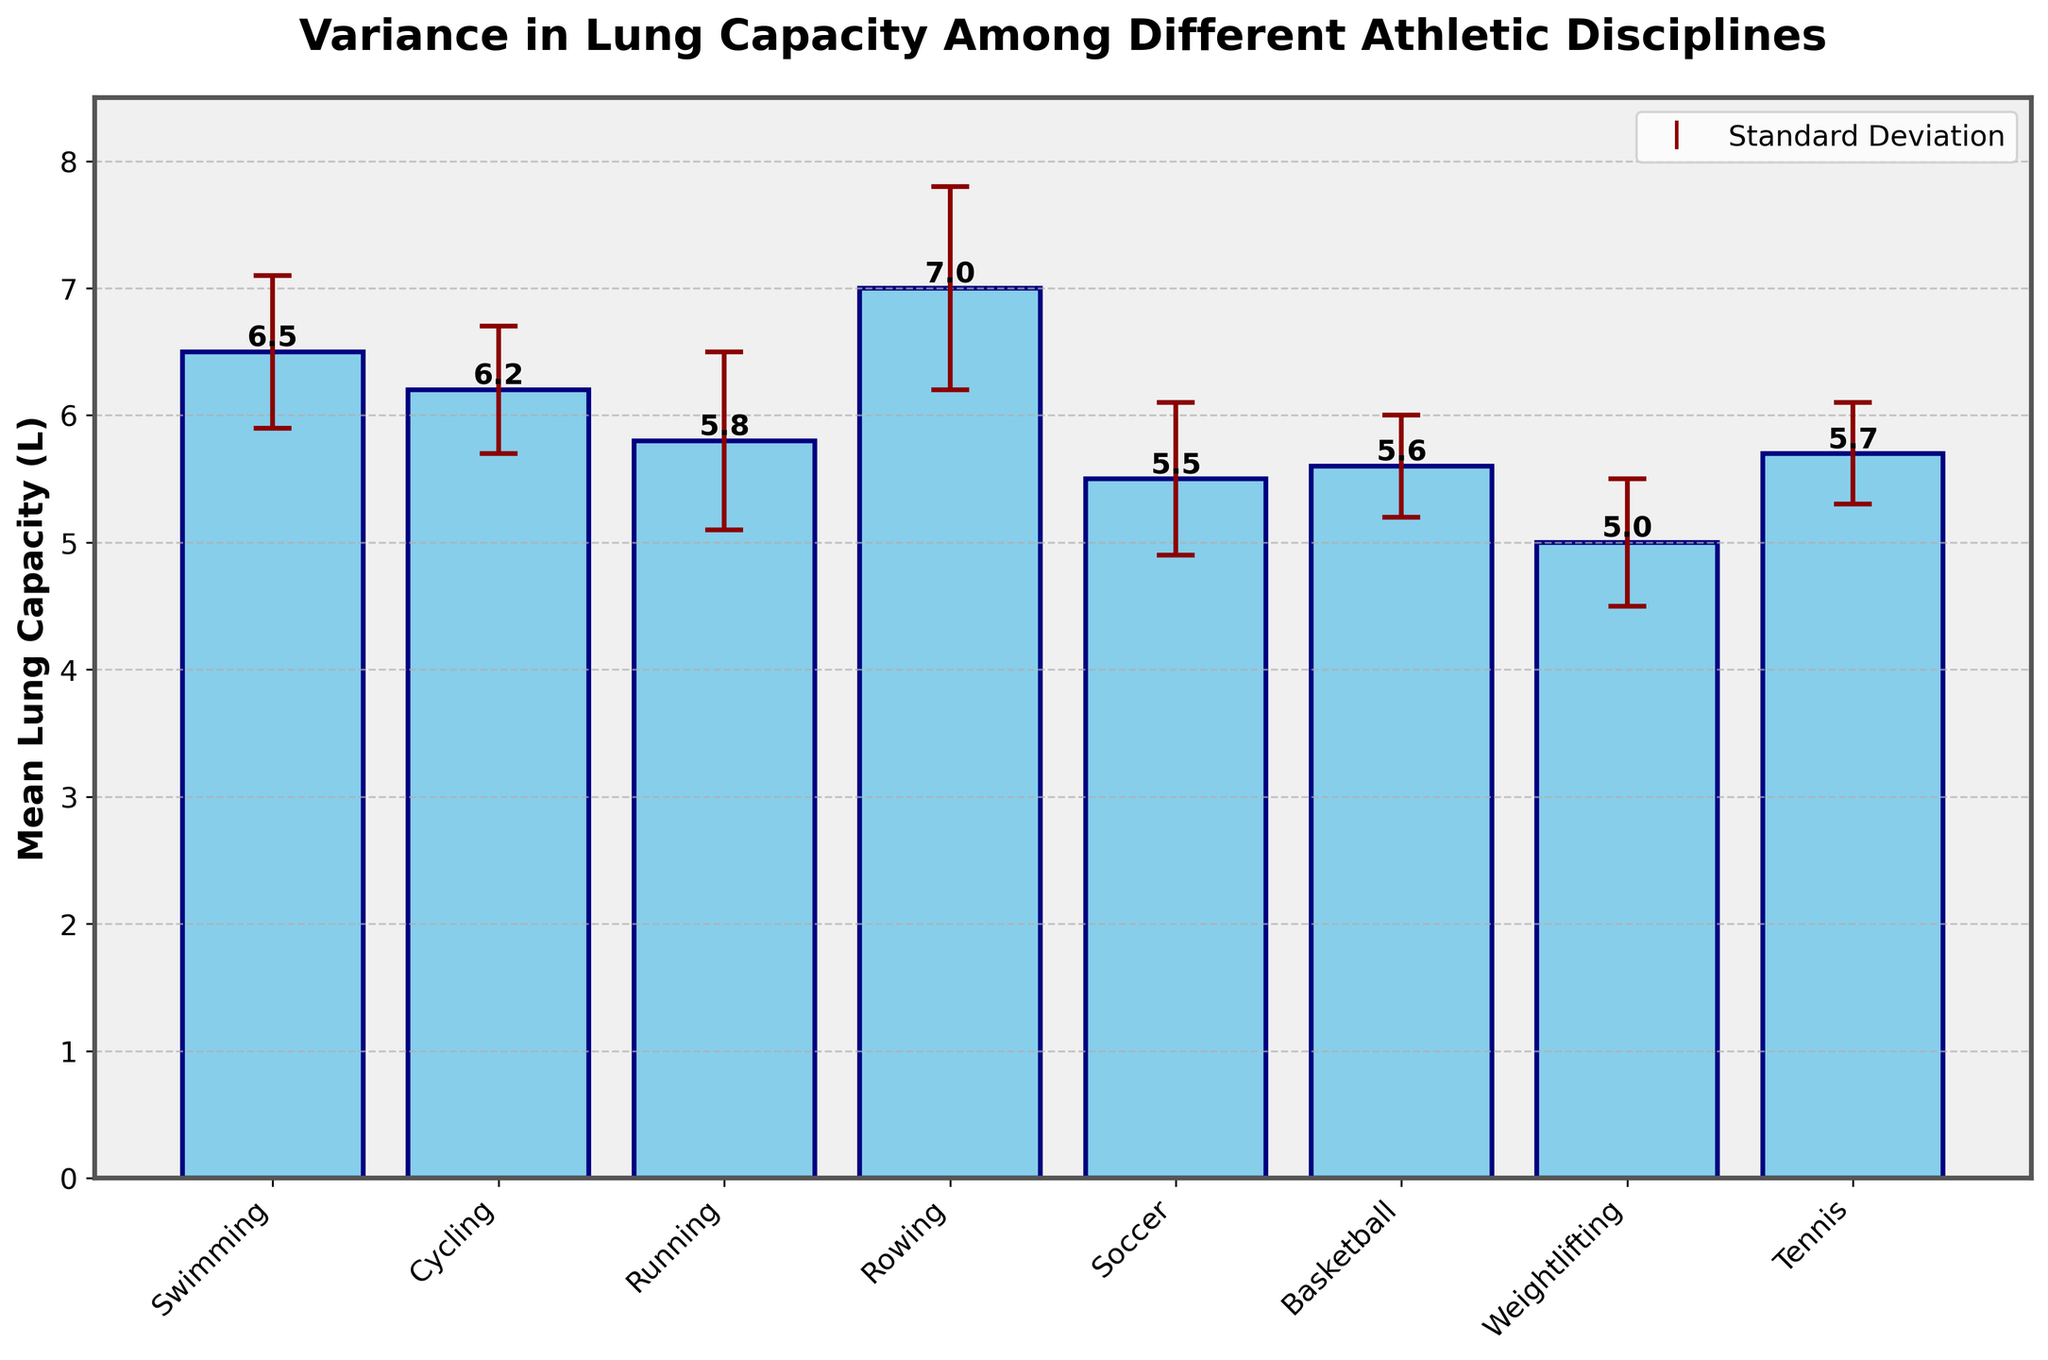How many athletic disciplines are compared in the figure? Count the number of bars in the bar chart, each representing a different athletic discipline.
Answer: 8 Which athletic discipline has the highest mean lung capacity? Look for the bar that reaches the highest point on the y-axis, which represents the mean lung capacity.
Answer: Rowing What is the difference in mean lung capacity between Rowing and Tennis? Identify the mean lung capacities for Rowing (7.0 L) and Tennis (5.7 L), then subtract the lower value (Tennis) from the higher value (Rowing). 7.0 - 5.7 = 1.3
Answer: 1.3 L Which two athletic disciplines have the smallest standard deviations in lung capacity? Compare the error bars and identify the two with the shortest lengths, which signify the smallest standard deviations.
Answer: Basketball and Tennis Is the mean lung capacity of Soccer greater than that of Weightlifting? Compare the mean lung capacities indicated by the heights of the bars for Soccer (5.5 L) and Weightlifting (5.0 L).
Answer: Yes What is the average mean lung capacity of Swimming and Cycling combined? Find the mean lung capacities of Swimming (6.5 L) and Cycling (6.2 L), then compute the average: (6.5 + 6.2) / 2 = 6.35
Answer: 6.35 L Which athletic discipline has a mean lung capacity closest to 5.5 L? Look for the bar that is nearest to the 5.5 L mark on the y-axis. Soccer has a mean lung capacity of exactly 5.5 L.
Answer: Soccer What is the range of the mean lung capacities among all athletic disciplines? Identify the highest mean lung capacity (Rowing, 7.0 L) and the lowest mean lung capacity (Weightlifting, 5.0 L), then subtract the latter from the former. 7.0 - 5.0 = 2.0
Answer: 2.0 L Which two sports have mean lung capacities that differ by 0.1 L? Look for bars that have mean lung capacities with a difference of 0.1 L. Basketball (5.6 L) and Tennis (5.7 L) differ by exactly 0.1 L.
Answer: Basketball and Tennis Based on the error bars, which athletic discipline exhibits the greatest variability in lung capacity? Find the sport with the longest error bar, indicating the highest standard deviation.
Answer: Rowing 